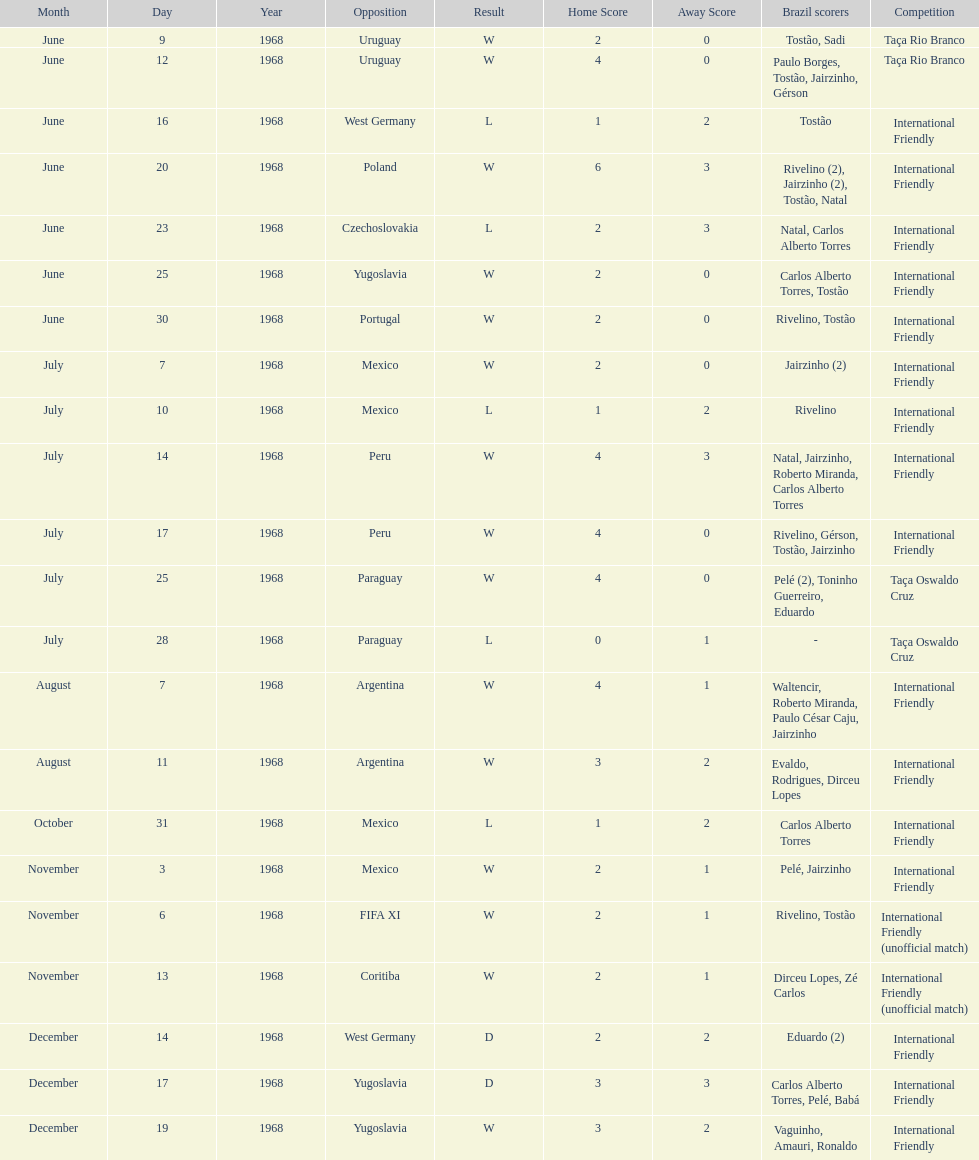Name the first competition ever played by brazil. Taça Rio Branco. 